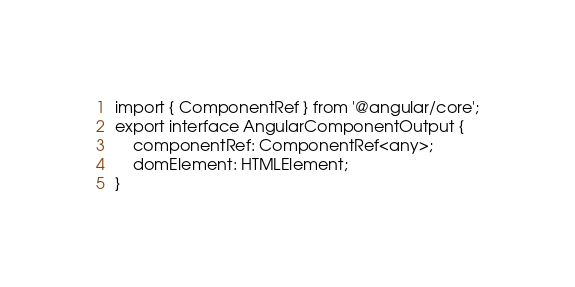Convert code to text. <code><loc_0><loc_0><loc_500><loc_500><_TypeScript_>import { ComponentRef } from '@angular/core';
export interface AngularComponentOutput {
    componentRef: ComponentRef<any>;
    domElement: HTMLElement;
}
</code> 